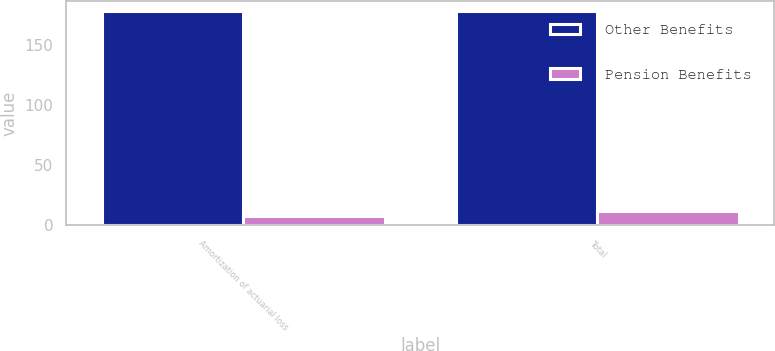Convert chart to OTSL. <chart><loc_0><loc_0><loc_500><loc_500><stacked_bar_chart><ecel><fcel>Amortization of actuarial loss<fcel>Total<nl><fcel>Other Benefits<fcel>178<fcel>178<nl><fcel>Pension Benefits<fcel>8<fcel>12<nl></chart> 